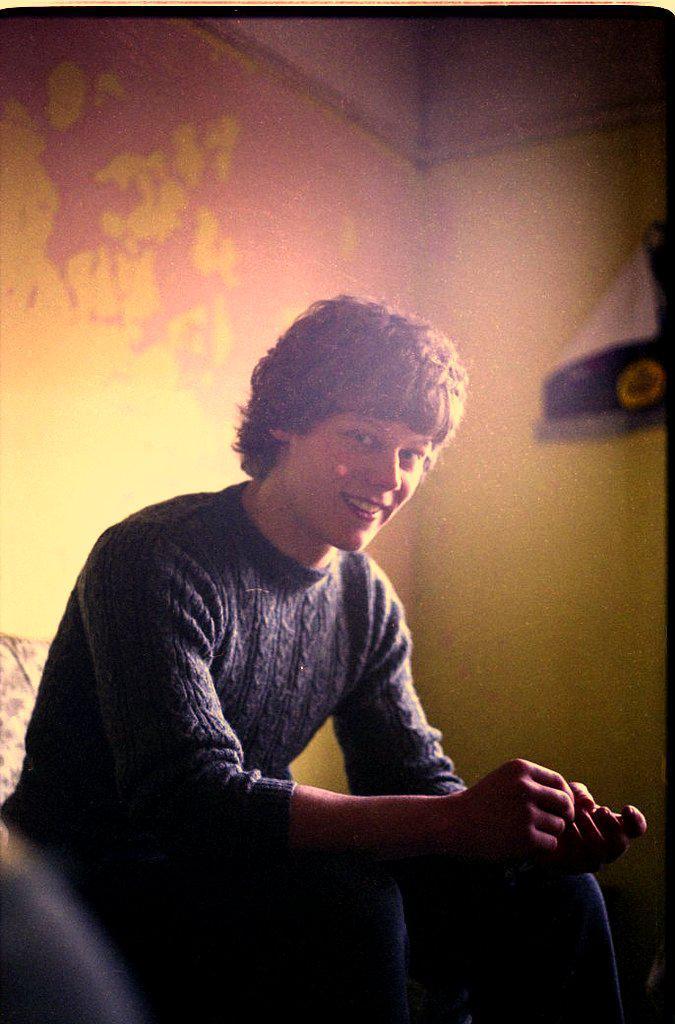Describe this image in one or two sentences. At the center of the image there is a person sitting on a sofa. In the background there is a wall. 